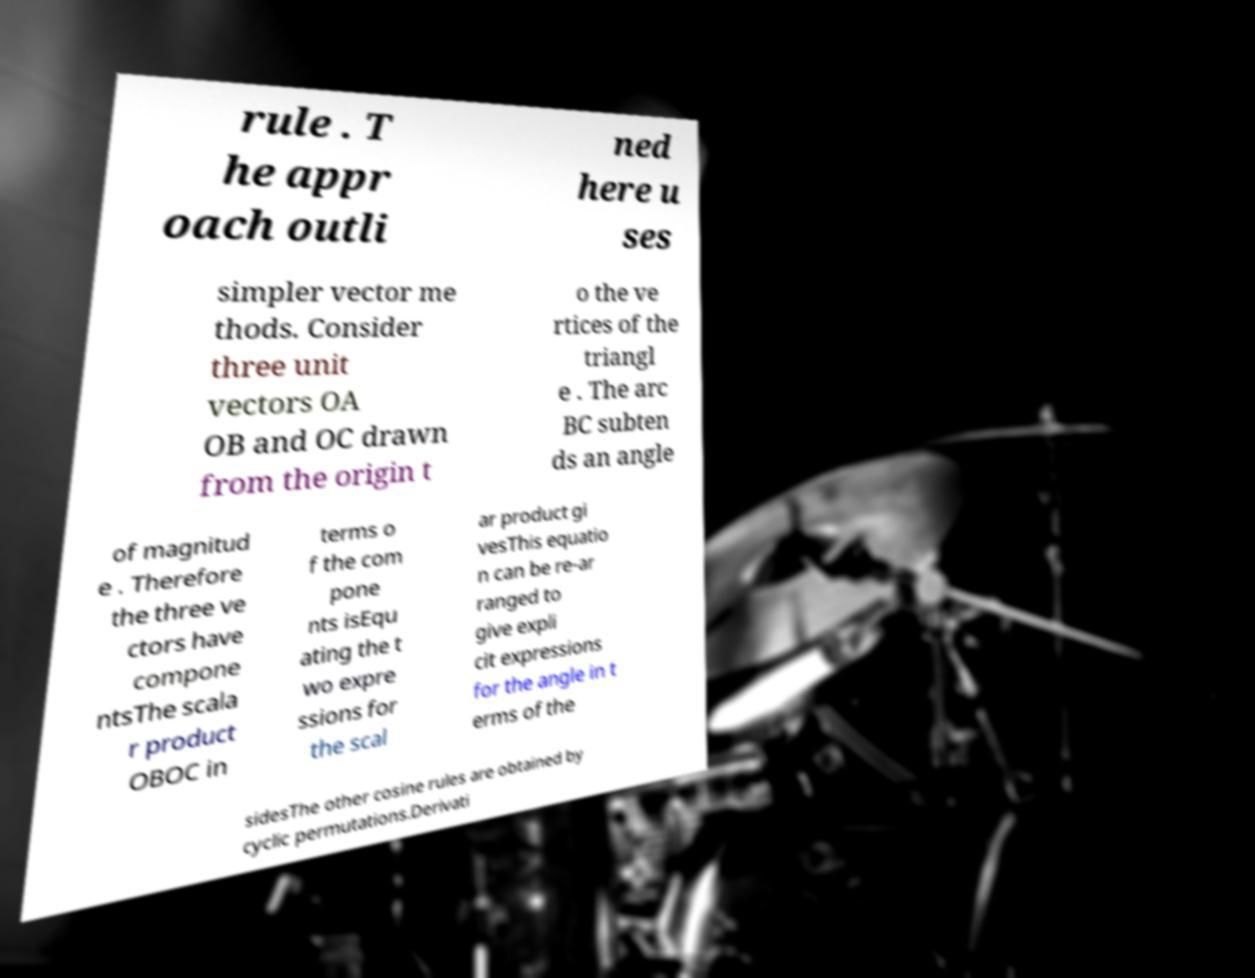Please identify and transcribe the text found in this image. rule . T he appr oach outli ned here u ses simpler vector me thods. Consider three unit vectors OA OB and OC drawn from the origin t o the ve rtices of the triangl e . The arc BC subten ds an angle of magnitud e . Therefore the three ve ctors have compone ntsThe scala r product OBOC in terms o f the com pone nts isEqu ating the t wo expre ssions for the scal ar product gi vesThis equatio n can be re-ar ranged to give expli cit expressions for the angle in t erms of the sidesThe other cosine rules are obtained by cyclic permutations.Derivati 